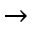Convert formula to latex. <formula><loc_0><loc_0><loc_500><loc_500>\rightarrow</formula> 